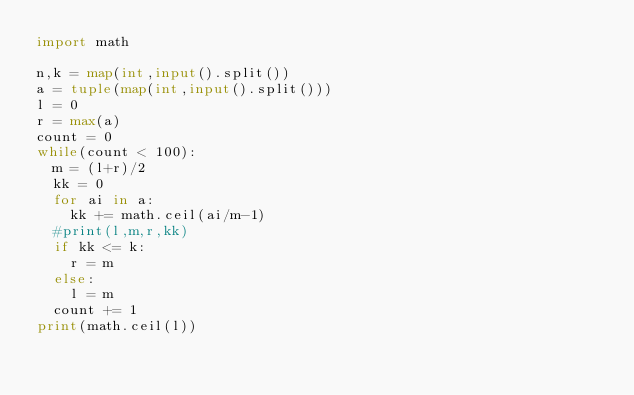Convert code to text. <code><loc_0><loc_0><loc_500><loc_500><_Python_>import math

n,k = map(int,input().split())
a = tuple(map(int,input().split()))
l = 0
r = max(a)
count = 0
while(count < 100):
  m = (l+r)/2
  kk = 0
  for ai in a:
    kk += math.ceil(ai/m-1)
  #print(l,m,r,kk)
  if kk <= k:
    r = m
  else:
    l = m
  count += 1
print(math.ceil(l))</code> 